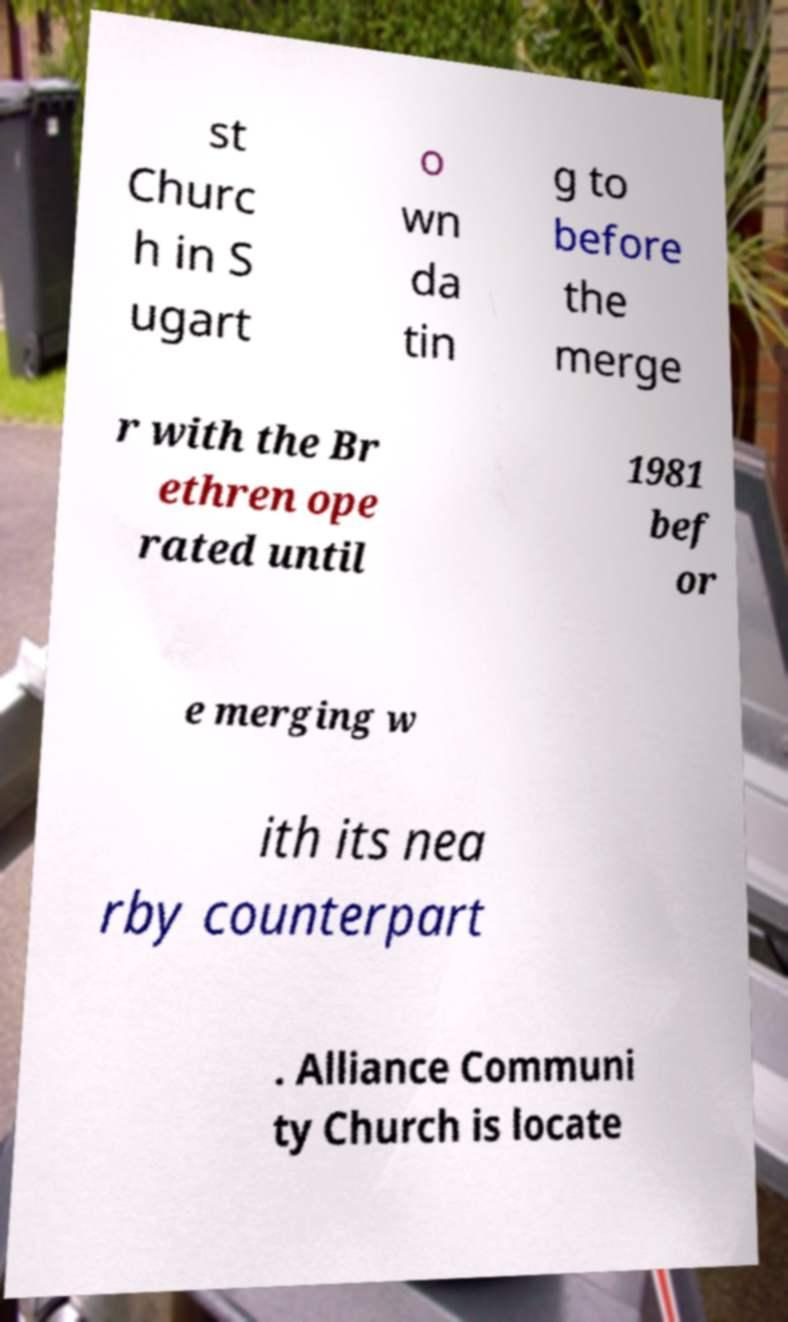There's text embedded in this image that I need extracted. Can you transcribe it verbatim? st Churc h in S ugart o wn da tin g to before the merge r with the Br ethren ope rated until 1981 bef or e merging w ith its nea rby counterpart . Alliance Communi ty Church is locate 